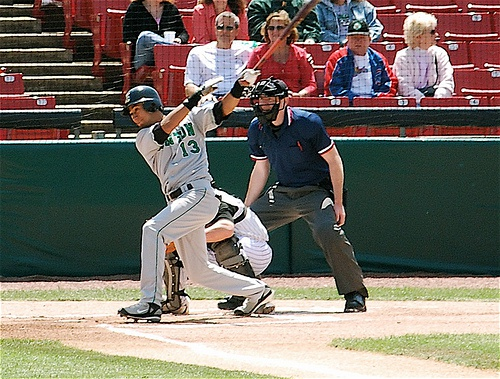Describe the objects in this image and their specific colors. I can see people in black, darkgray, and lightgray tones, people in black, gray, and maroon tones, people in black, lavender, darkgray, and gray tones, people in black, navy, darkgray, and brown tones, and people in black, white, darkgray, and brown tones in this image. 